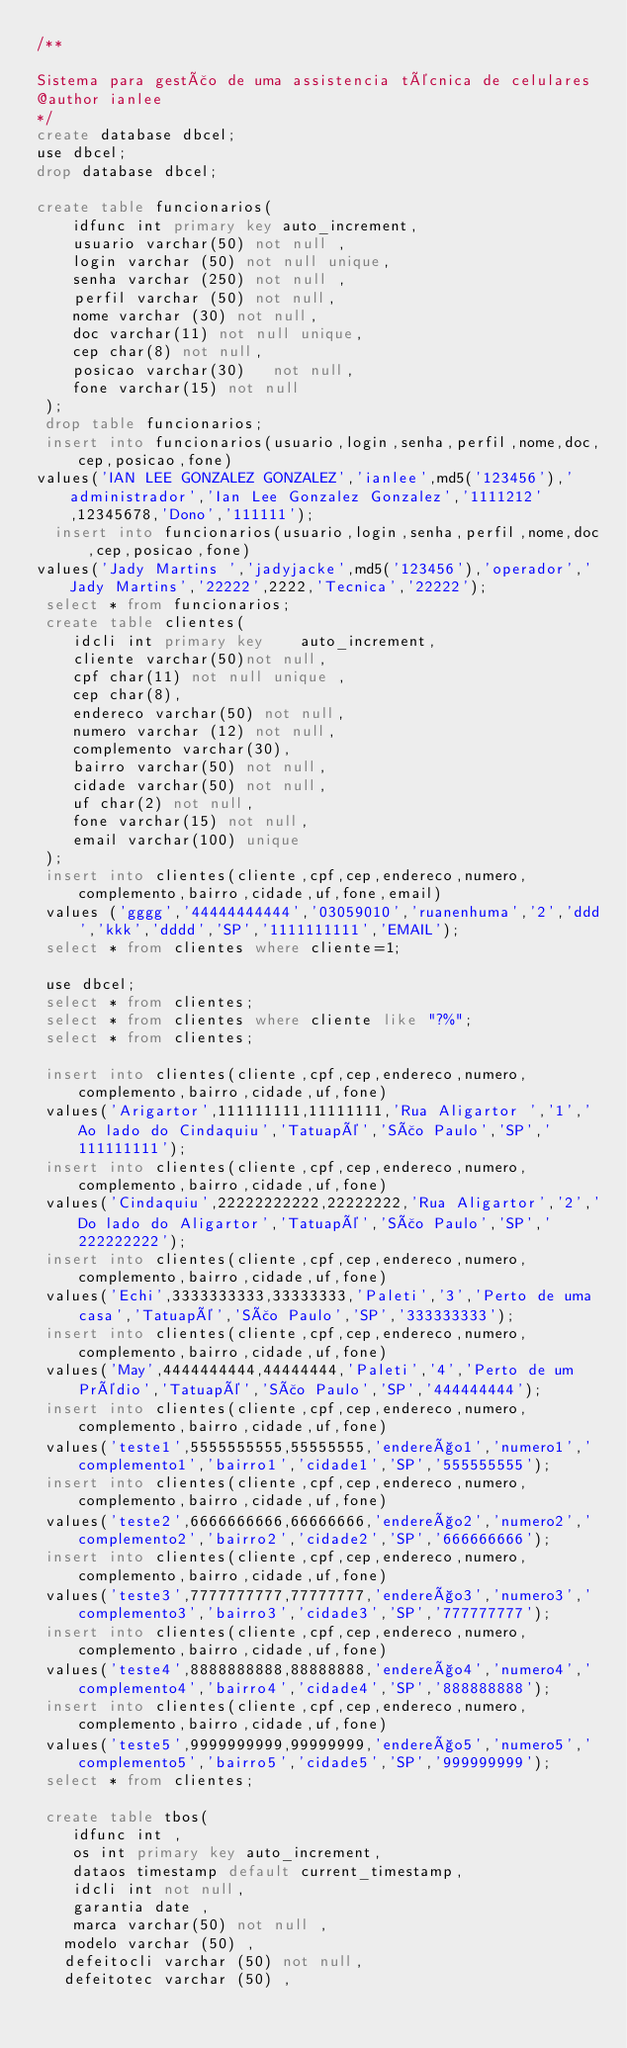<code> <loc_0><loc_0><loc_500><loc_500><_SQL_>/**

Sistema para gestão de uma assistencia técnica de celulares
@author ianlee
*/
create database dbcel;
use dbcel;
drop database dbcel;

create table funcionarios( 
	idfunc int primary key auto_increment,
	usuario varchar(50) not null , 
	login varchar (50) not null unique,
	senha varchar (250) not null ,
	perfil varchar (50) not null,
	nome varchar (30) not null,
	doc varchar(11) not null unique,
	cep char(8) not null,
	posicao varchar(30)   not null,
	fone varchar(15) not null
 );
 drop table funcionarios;
 insert into funcionarios(usuario,login,senha,perfil,nome,doc,cep,posicao,fone)
values('IAN LEE GONZALEZ GONZALEZ','ianlee',md5('123456'),'administrador','Ian Lee Gonzalez Gonzalez','1111212',12345678,'Dono','111111');
  insert into funcionarios(usuario,login,senha,perfil,nome,doc,cep,posicao,fone)
values('Jady Martins ','jadyjacke',md5('123456'),'operador','Jady Martins','22222',2222,'Tecnica','22222');
 select * from funcionarios;
 create table clientes(
	idcli int primary key	 auto_increment,
	cliente varchar(50)not null,
	cpf char(11) not null unique ,
	cep char(8),
	endereco varchar(50) not null,
	numero varchar (12) not null,
	complemento varchar(30),
	bairro varchar(50) not null,
	cidade varchar(50) not null,
	uf char(2) not null,
	fone varchar(15) not null,
	email varchar(100) unique 
 );
 insert into clientes(cliente,cpf,cep,endereco,numero,complemento,bairro,cidade,uf,fone,email) 
 values ('gggg','44444444444','03059010','ruanenhuma','2','ddd','kkk','dddd','SP','1111111111','EMAIL');
 select * from clientes where cliente=1;
 
 use dbcel;
 select * from clientes;
 select * from clientes where cliente like "?%";
 select * from clientes;
 
 insert into clientes(cliente,cpf,cep,endereco,numero,complemento,bairro,cidade,uf,fone)
 values('Arigartor',111111111,11111111,'Rua Aligartor ','1','Ao lado do Cindaquiu','Tatuapé','São Paulo','SP','111111111');
 insert into clientes(cliente,cpf,cep,endereco,numero,complemento,bairro,cidade,uf,fone)
 values('Cindaquiu',22222222222,22222222,'Rua Aligartor','2','Do lado do Aligartor','Tatuapé','São Paulo','SP','222222222');
 insert into clientes(cliente,cpf,cep,endereco,numero,complemento,bairro,cidade,uf,fone)
 values('Echi',3333333333,33333333,'Paleti','3','Perto de uma casa','Tatuapé','São Paulo','SP','333333333');
 insert into clientes(cliente,cpf,cep,endereco,numero,complemento,bairro,cidade,uf,fone)
 values('May',4444444444,44444444,'Paleti','4','Perto de um Prédio','Tatuapé','São Paulo','SP','444444444');
 insert into clientes(cliente,cpf,cep,endereco,numero,complemento,bairro,cidade,uf,fone)
 values('teste1',5555555555,55555555,'endereço1','numero1','complemento1','bairro1','cidade1','SP','555555555');
 insert into clientes(cliente,cpf,cep,endereco,numero,complemento,bairro,cidade,uf,fone)
 values('teste2',6666666666,66666666,'endereço2','numero2','complemento2','bairro2','cidade2','SP','666666666');
 insert into clientes(cliente,cpf,cep,endereco,numero,complemento,bairro,cidade,uf,fone)
 values('teste3',7777777777,77777777,'endereço3','numero3','complemento3','bairro3','cidade3','SP','777777777');
 insert into clientes(cliente,cpf,cep,endereco,numero,complemento,bairro,cidade,uf,fone)
 values('teste4',8888888888,88888888,'endereço4','numero4','complemento4','bairro4','cidade4','SP','888888888');
 insert into clientes(cliente,cpf,cep,endereco,numero,complemento,bairro,cidade,uf,fone)
 values('teste5',9999999999,99999999,'endereço5','numero5','complemento5','bairro5','cidade5','SP','999999999');
 select * from clientes;
 
 create table tbos(
	idfunc int ,
	os int primary key auto_increment,
	dataos timestamp default current_timestamp,
	idcli int not null,
	garantia date ,
	marca varchar(50) not null ,
   modelo varchar (50) ,
   defeitocli varchar (50) not null,
   defeitotec varchar (50) ,</code> 